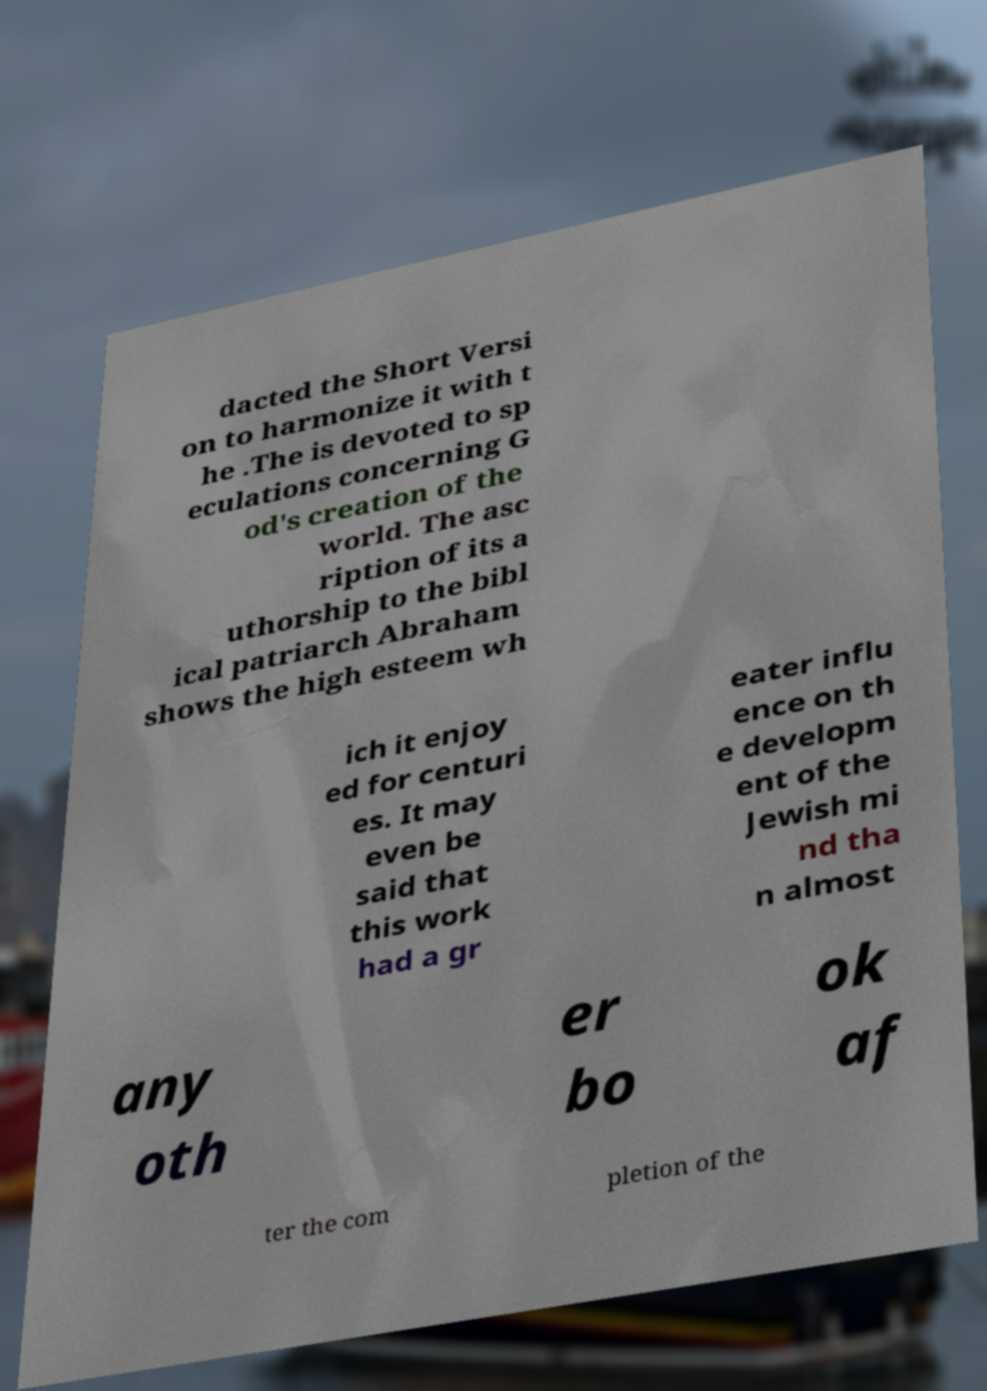Please identify and transcribe the text found in this image. dacted the Short Versi on to harmonize it with t he .The is devoted to sp eculations concerning G od's creation of the world. The asc ription of its a uthorship to the bibl ical patriarch Abraham shows the high esteem wh ich it enjoy ed for centuri es. It may even be said that this work had a gr eater influ ence on th e developm ent of the Jewish mi nd tha n almost any oth er bo ok af ter the com pletion of the 